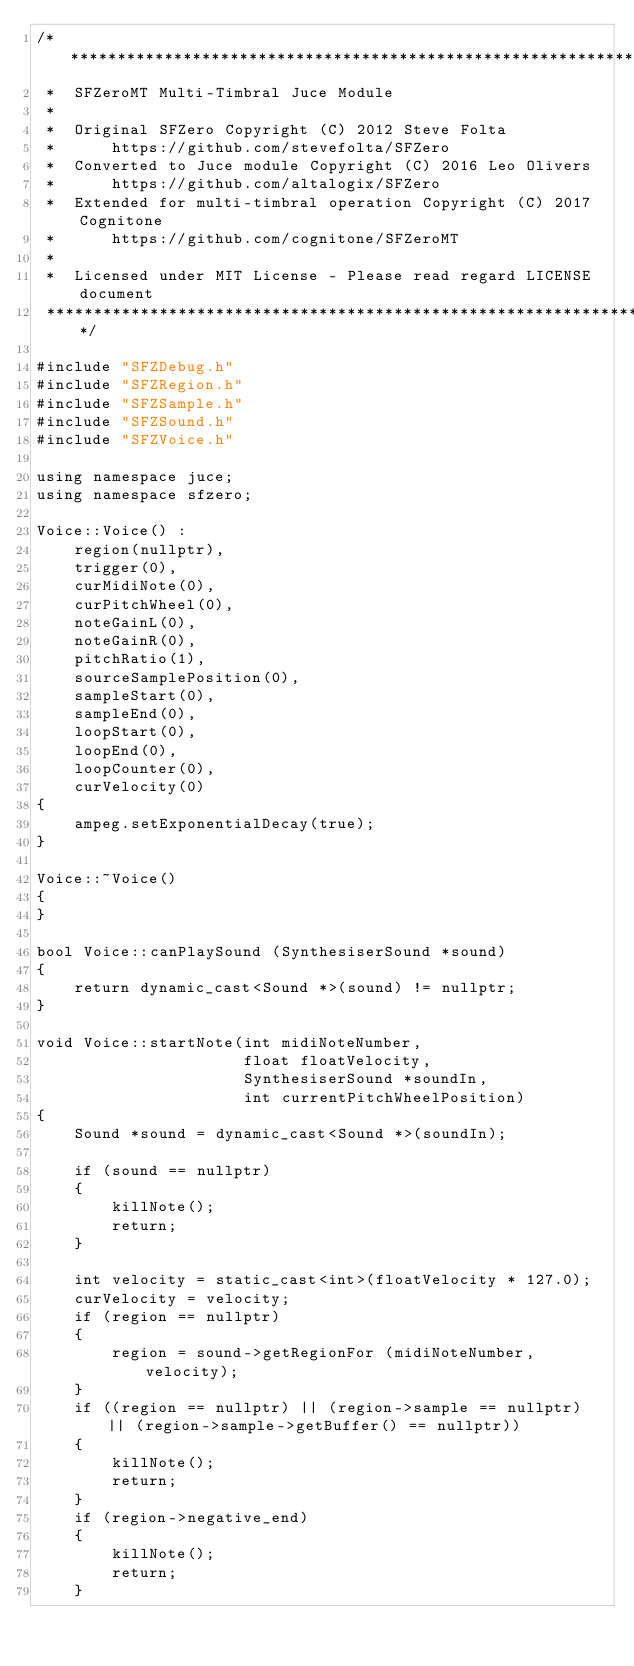<code> <loc_0><loc_0><loc_500><loc_500><_C++_>/***********************************************************************
 *  SFZeroMT Multi-Timbral Juce Module
 *
 *  Original SFZero Copyright (C) 2012 Steve Folta
 *      https://github.com/stevefolta/SFZero
 *  Converted to Juce module Copyright (C) 2016 Leo Olivers
 *      https://github.com/altalogix/SFZero
 *  Extended for multi-timbral operation Copyright (C) 2017 Cognitone
 *      https://github.com/cognitone/SFZeroMT
 *
 *  Licensed under MIT License - Please read regard LICENSE document
 ***********************************************************************/

#include "SFZDebug.h"
#include "SFZRegion.h"
#include "SFZSample.h"
#include "SFZSound.h"
#include "SFZVoice.h"

using namespace juce;
using namespace sfzero;

Voice::Voice() :
    region(nullptr),
    trigger(0),
    curMidiNote(0),
    curPitchWheel(0),
    noteGainL(0),
    noteGainR(0),
    pitchRatio(1),
    sourceSamplePosition(0),
    sampleStart(0),
    sampleEnd(0),
    loopStart(0),
    loopEnd(0),
    loopCounter(0),
    curVelocity(0)
{
    ampeg.setExponentialDecay(true);
}

Voice::~Voice()
{
}

bool Voice::canPlaySound (SynthesiserSound *sound)
{
    return dynamic_cast<Sound *>(sound) != nullptr;
}

void Voice::startNote(int midiNoteNumber,
                      float floatVelocity,
                      SynthesiserSound *soundIn,
                      int currentPitchWheelPosition)
{
    Sound *sound = dynamic_cast<Sound *>(soundIn);
    
    if (sound == nullptr)
    {
        killNote();
        return;
    }
    
    int velocity = static_cast<int>(floatVelocity * 127.0);
    curVelocity = velocity;
    if (region == nullptr)
    {
        region = sound->getRegionFor (midiNoteNumber, velocity);
    }
    if ((region == nullptr) || (region->sample == nullptr) || (region->sample->getBuffer() == nullptr))
    {
        killNote();
        return;
    }
    if (region->negative_end)
    {
        killNote();
        return;
    }
    </code> 